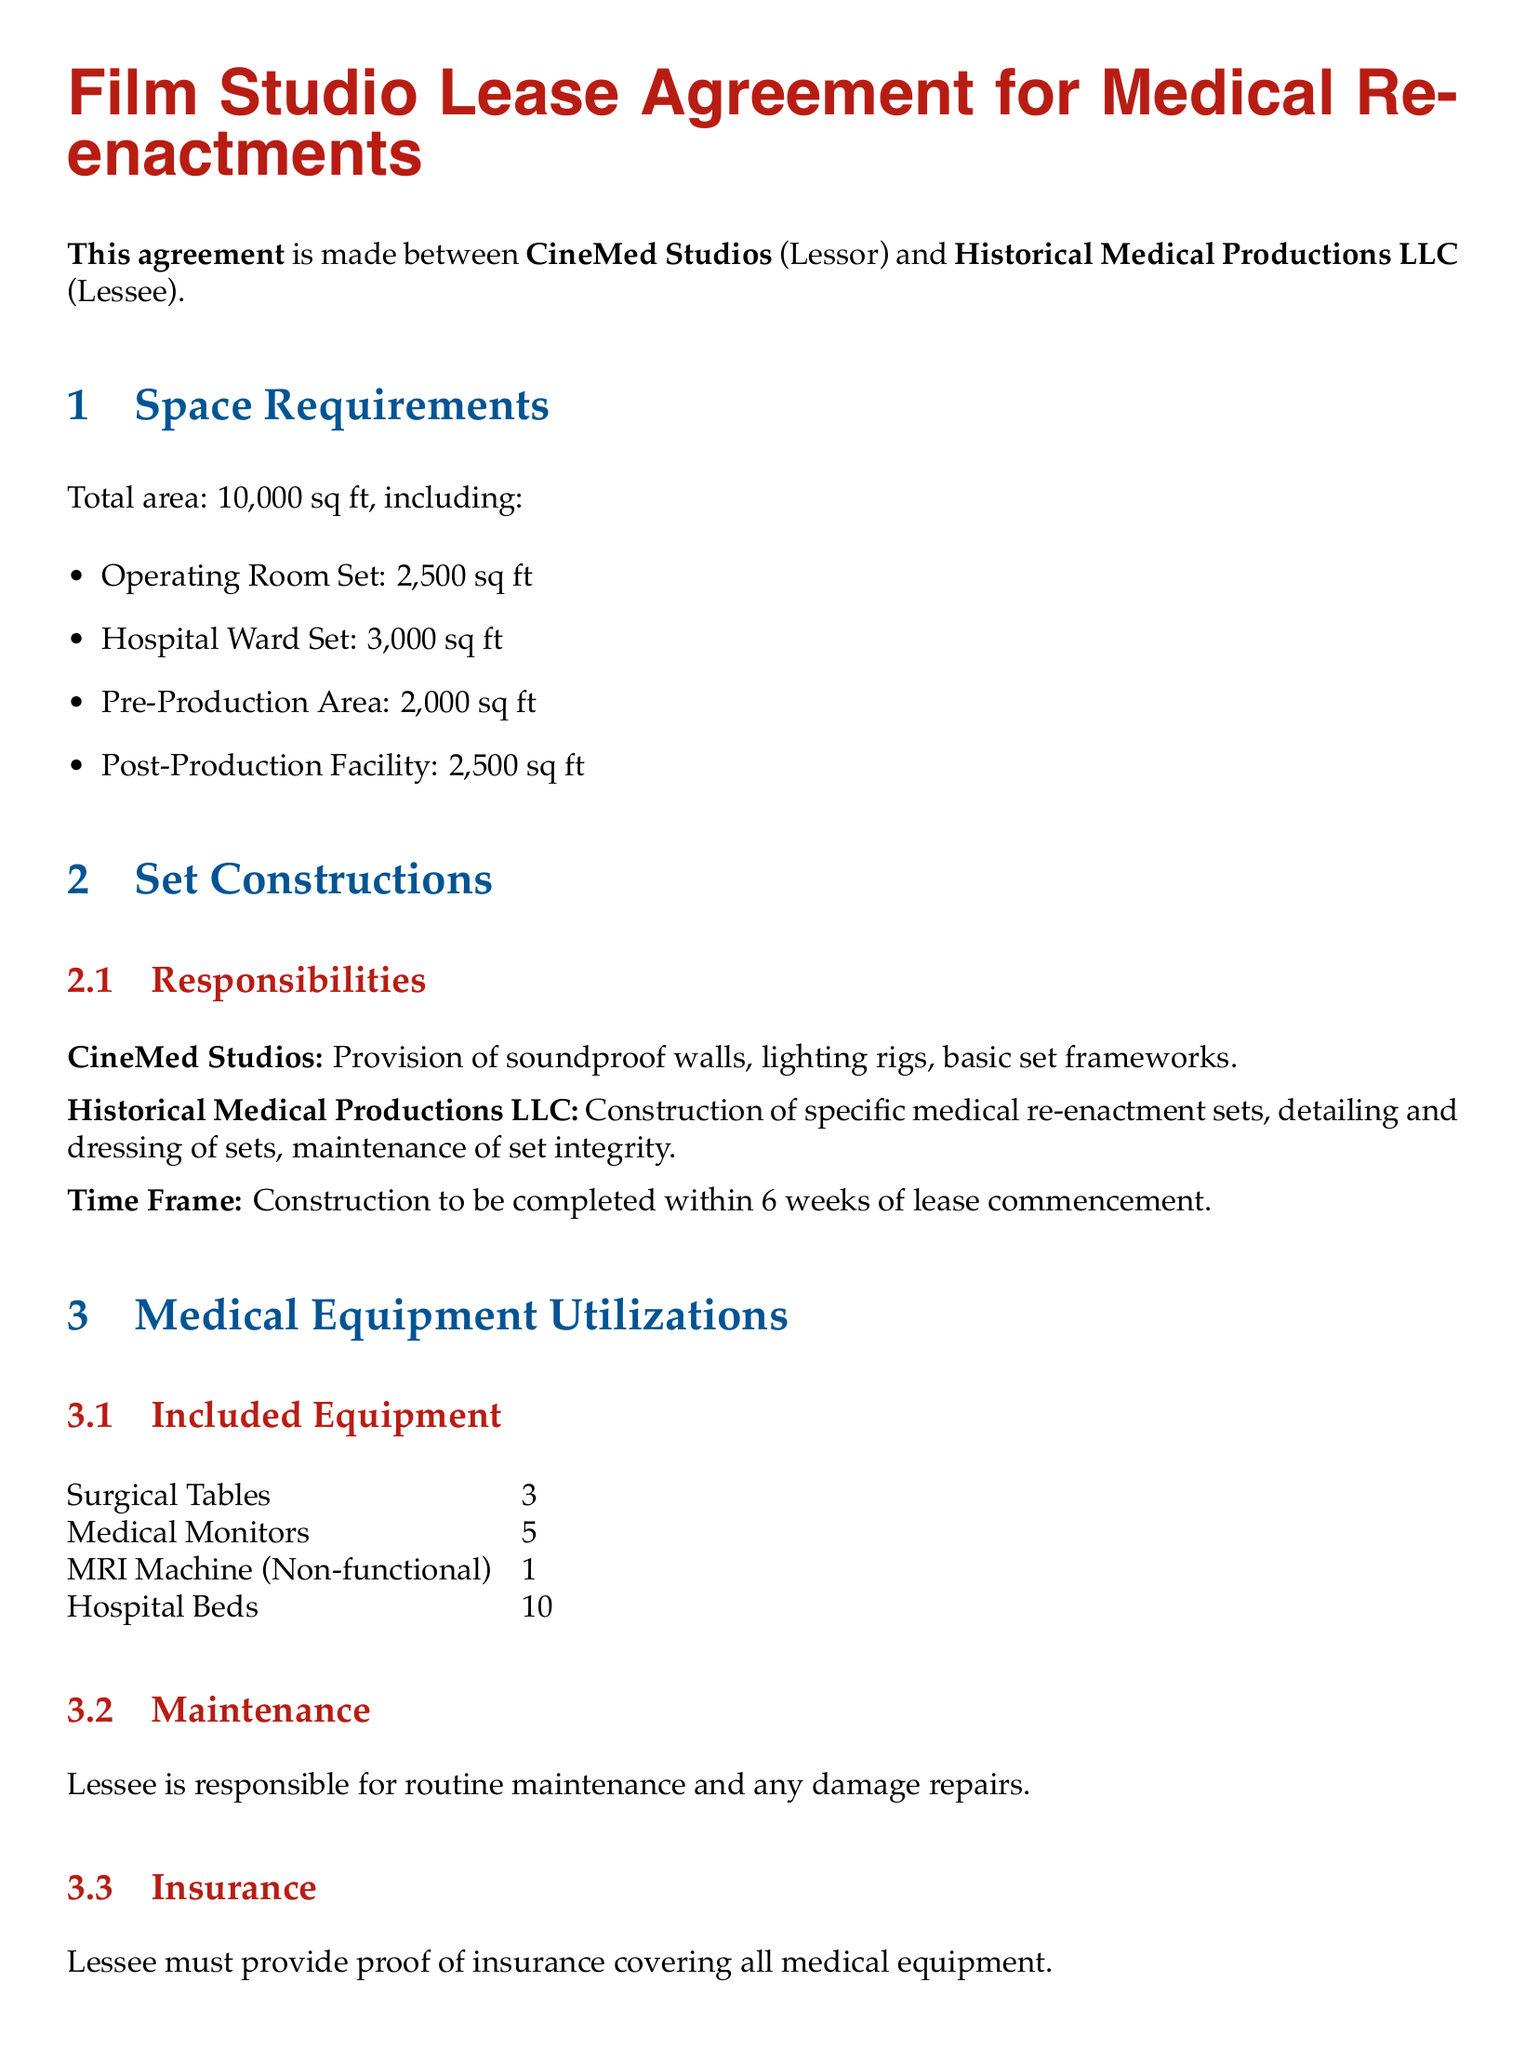What is the total area of the studio? The total area is specified in the document and includes all designated spaces.
Answer: 10,000 sq ft How many hospital beds are included? The document lists the number of hospital beds under the included equipment section.
Answer: 10 Who is responsible for construction of specific medical sets? Responsibilities for set construction are detailed, indicating who handles specific tasks.
Answer: Historical Medical Productions LLC What is the duration of the lease? The lease duration is specified by its start and end dates.
Answer: 1 year What is the early termination fee? The document explicitly states the fee associated with early termination of the lease.
Answer: $20,000 What is the monthly rent? The rent amount is provided in the financial terms section of the lease agreement.
Answer: $50,000 What is the notice period for termination? The document outlines the required notice period for lease termination in the corresponding clause.
Answer: 60 days How many MRI machines are provided? The quantity of MRI machines included in the medical equipment section is stated explicitly.
Answer: 1 